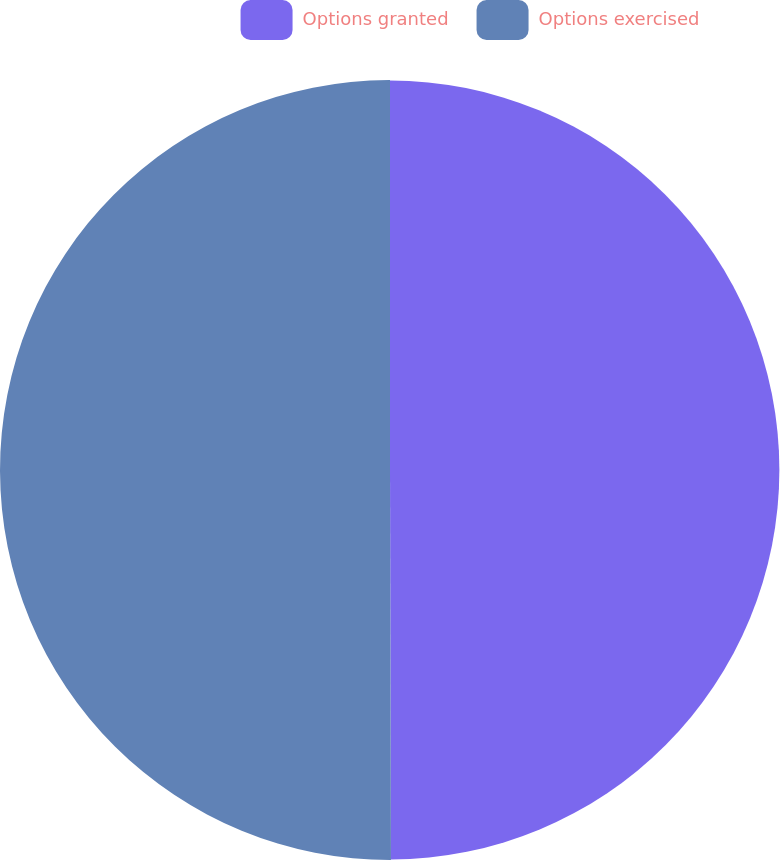Convert chart. <chart><loc_0><loc_0><loc_500><loc_500><pie_chart><fcel>Options granted<fcel>Options exercised<nl><fcel>49.96%<fcel>50.04%<nl></chart> 